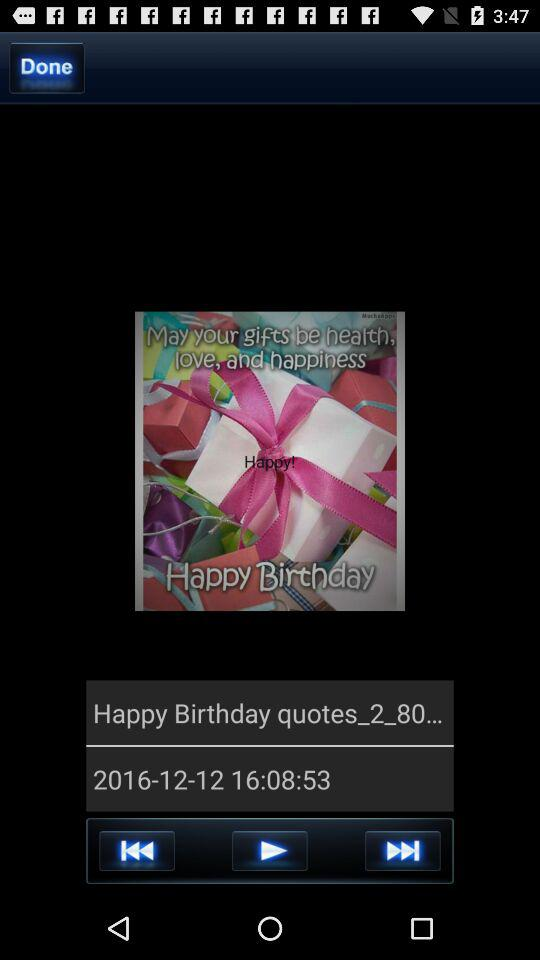What is the date? The date is December 12, 2016. 